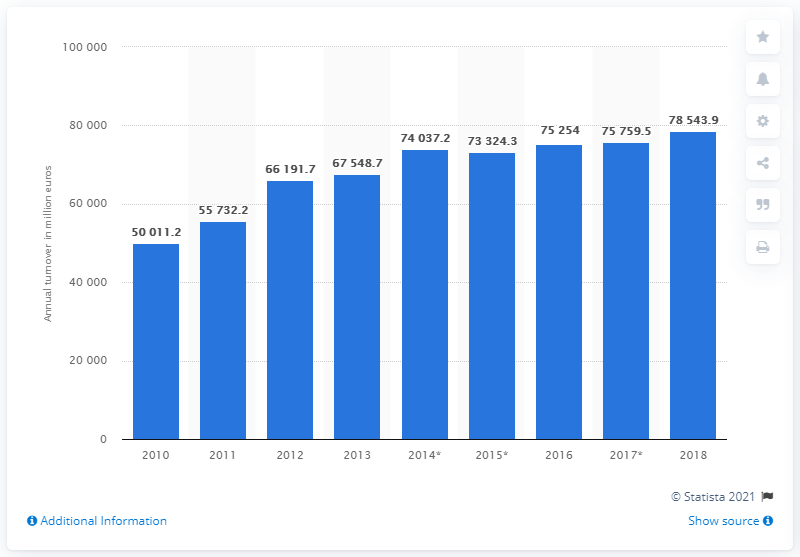Specify some key components in this picture. In 2017, the turnover of the building construction industry in France was 785,439.9 million euros. The turnover of the French building construction industry in 2017 was 75,759.5. 